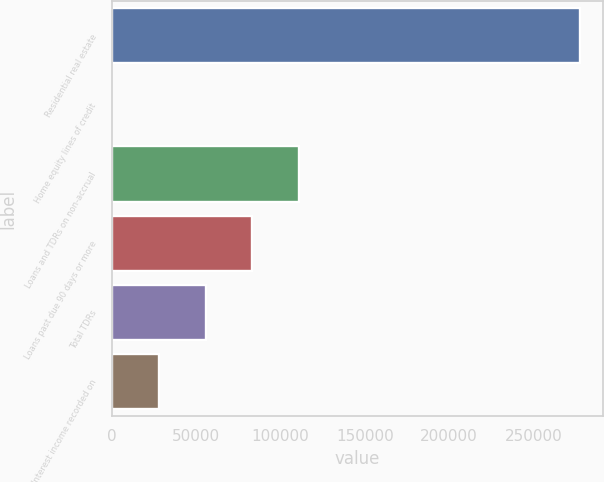Convert chart. <chart><loc_0><loc_0><loc_500><loc_500><bar_chart><fcel>Residential real estate<fcel>Home equity lines of credit<fcel>Loans and TDRs on non-accrual<fcel>Loans past due 90 days or more<fcel>Total TDRs<fcel>Interest income recorded on<nl><fcel>277253<fcel>170<fcel>111003<fcel>83294.9<fcel>55586.6<fcel>27878.3<nl></chart> 